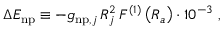Convert formula to latex. <formula><loc_0><loc_0><loc_500><loc_500>\Delta E _ { n p } \equiv - g _ { n p , j } \, R _ { j } ^ { 2 } \, F ^ { ( 1 ) } \left ( R _ { a } \right ) \cdot 1 0 ^ { - 3 } \ ,</formula> 